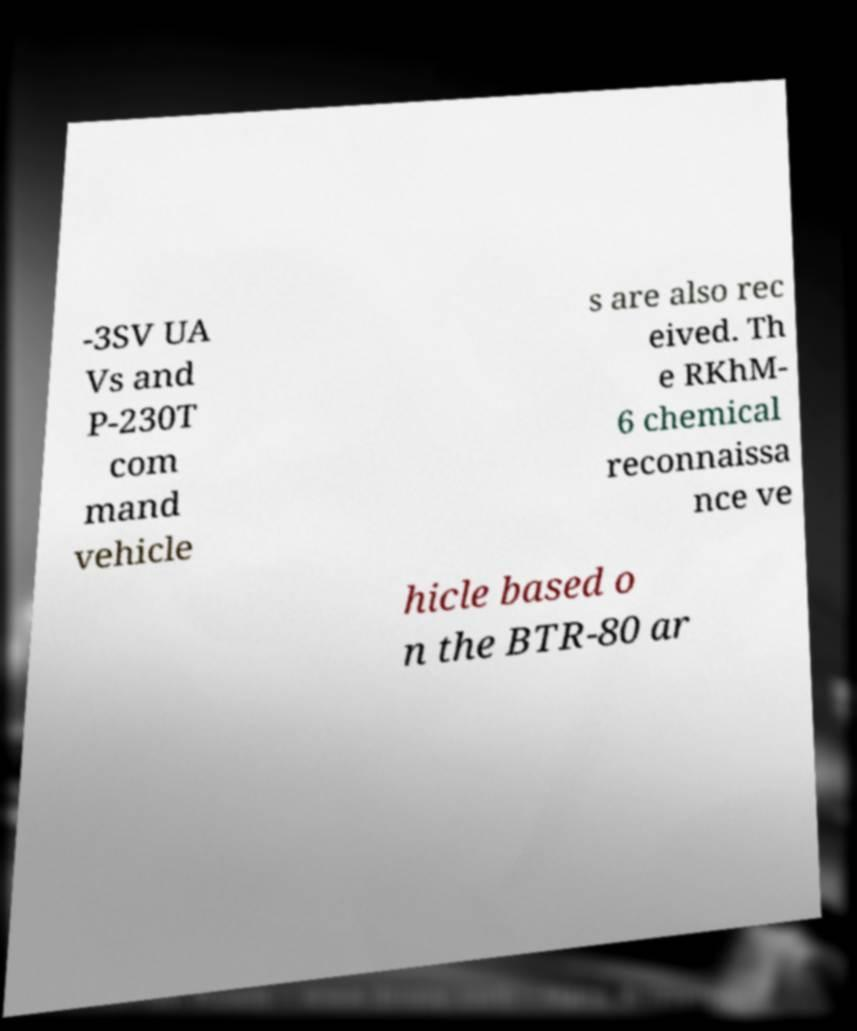Could you assist in decoding the text presented in this image and type it out clearly? -3SV UA Vs and P-230T com mand vehicle s are also rec eived. Th e RKhM- 6 chemical reconnaissa nce ve hicle based o n the BTR-80 ar 